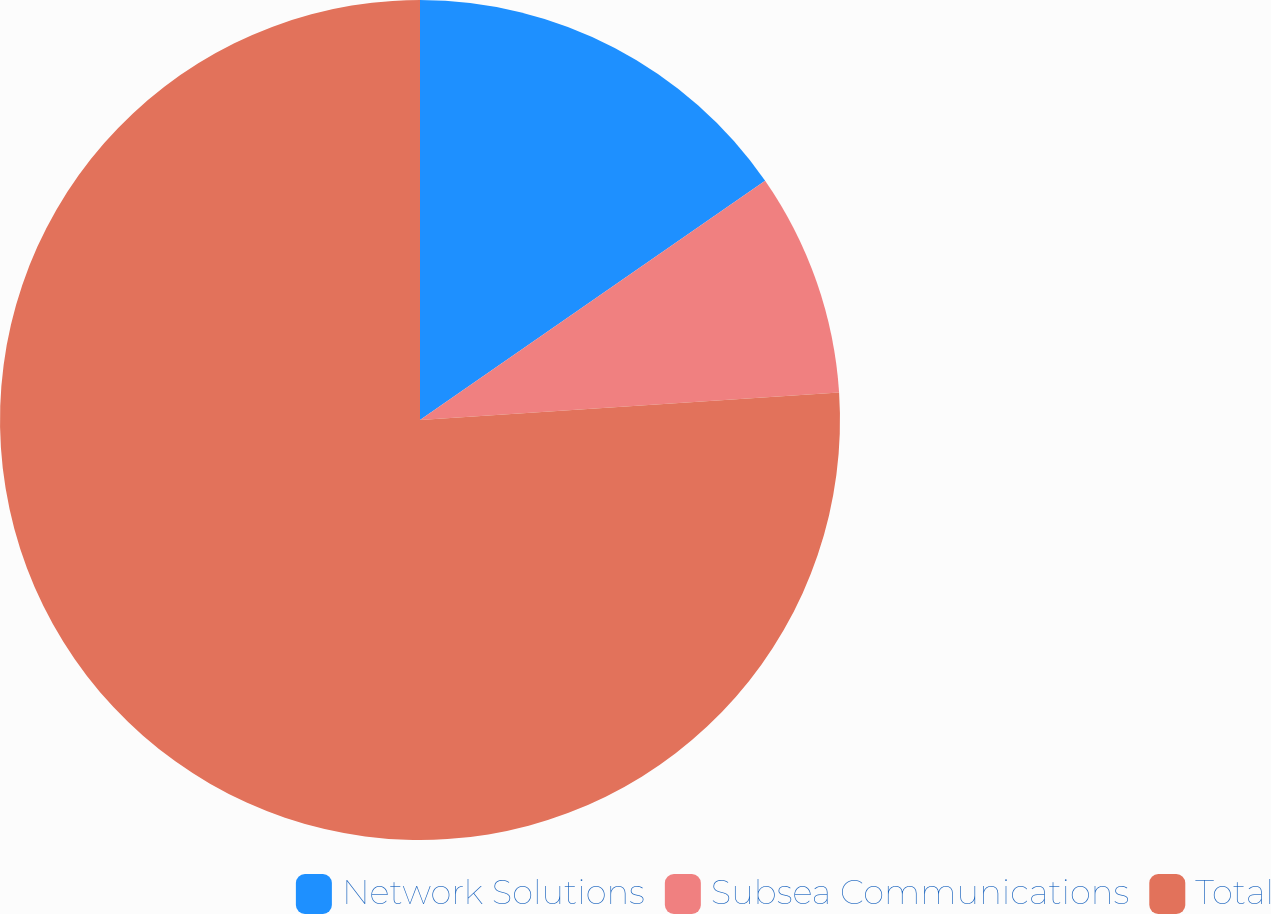<chart> <loc_0><loc_0><loc_500><loc_500><pie_chart><fcel>Network Solutions<fcel>Subsea Communications<fcel>Total<nl><fcel>15.35%<fcel>8.61%<fcel>76.04%<nl></chart> 